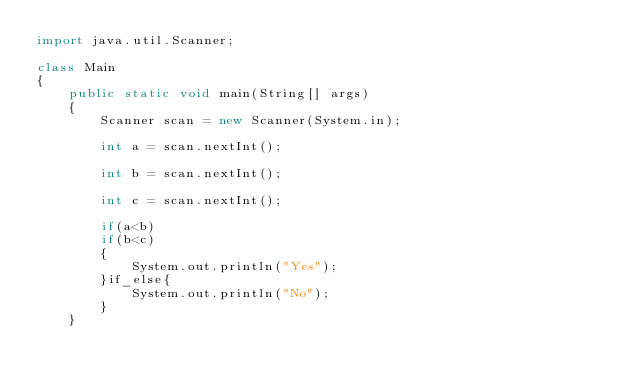Convert code to text. <code><loc_0><loc_0><loc_500><loc_500><_Java_>import java.util.Scanner;

class Main
{
    public static void main(String[] args)
    {
        Scanner scan = new Scanner(System.in);
        
        int a = scan.nextInt();
        
        int b = scan.nextInt();
        
        int c = scan.nextInt();
        
        if(a<b)
        if(b<c)
        {
            System.out.println("Yes");
        }if_else{
            System.out.println("No");
        }
    }
            


</code> 